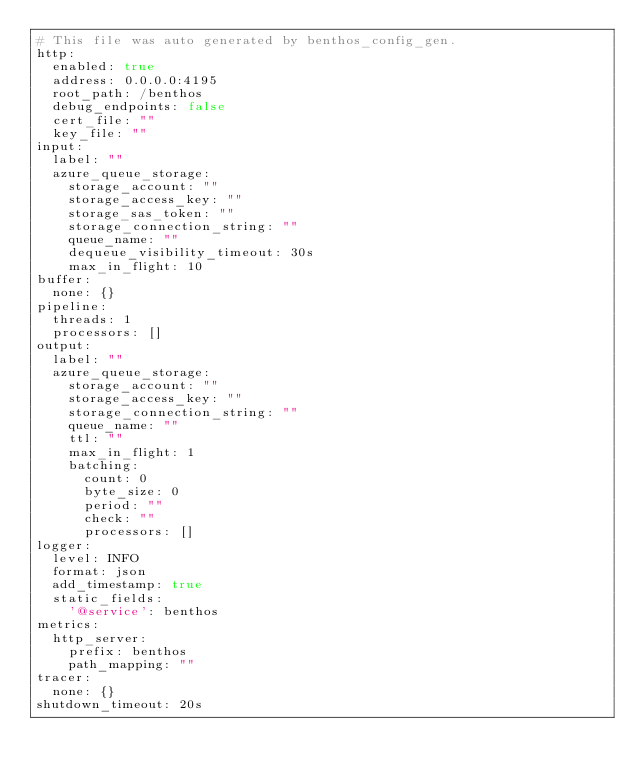Convert code to text. <code><loc_0><loc_0><loc_500><loc_500><_YAML_># This file was auto generated by benthos_config_gen.
http:
  enabled: true
  address: 0.0.0.0:4195
  root_path: /benthos
  debug_endpoints: false
  cert_file: ""
  key_file: ""
input:
  label: ""
  azure_queue_storage:
    storage_account: ""
    storage_access_key: ""
    storage_sas_token: ""
    storage_connection_string: ""
    queue_name: ""
    dequeue_visibility_timeout: 30s
    max_in_flight: 10
buffer:
  none: {}
pipeline:
  threads: 1
  processors: []
output:
  label: ""
  azure_queue_storage:
    storage_account: ""
    storage_access_key: ""
    storage_connection_string: ""
    queue_name: ""
    ttl: ""
    max_in_flight: 1
    batching:
      count: 0
      byte_size: 0
      period: ""
      check: ""
      processors: []
logger:
  level: INFO
  format: json
  add_timestamp: true
  static_fields:
    '@service': benthos
metrics:
  http_server:
    prefix: benthos
    path_mapping: ""
tracer:
  none: {}
shutdown_timeout: 20s
</code> 